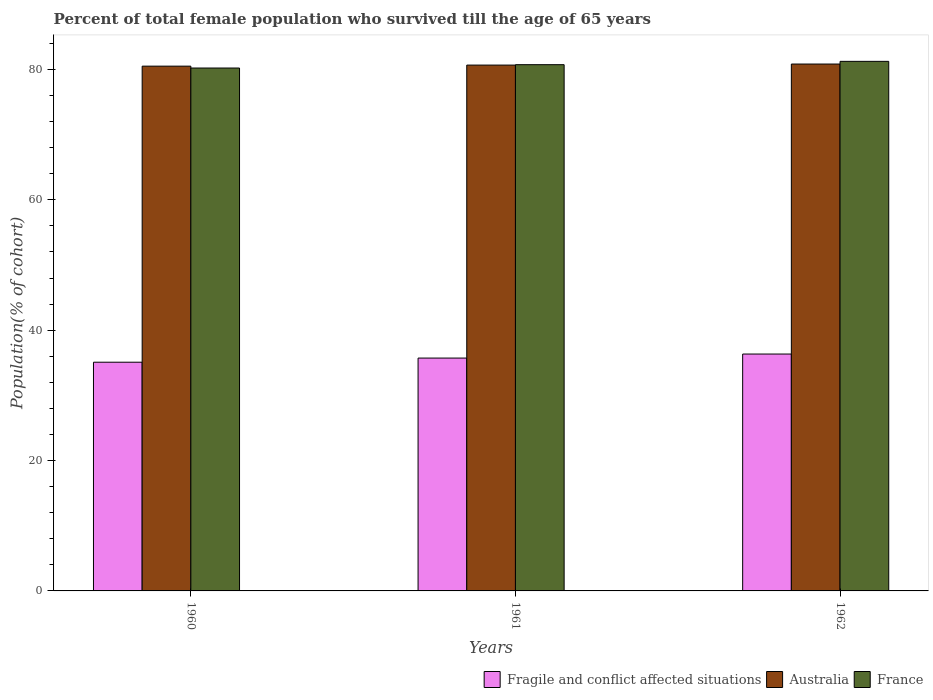How many different coloured bars are there?
Your answer should be compact. 3. How many groups of bars are there?
Offer a terse response. 3. What is the percentage of total female population who survived till the age of 65 years in France in 1960?
Your answer should be very brief. 80.21. Across all years, what is the maximum percentage of total female population who survived till the age of 65 years in Australia?
Keep it short and to the point. 80.82. Across all years, what is the minimum percentage of total female population who survived till the age of 65 years in France?
Ensure brevity in your answer.  80.21. In which year was the percentage of total female population who survived till the age of 65 years in France maximum?
Keep it short and to the point. 1962. In which year was the percentage of total female population who survived till the age of 65 years in Australia minimum?
Your response must be concise. 1960. What is the total percentage of total female population who survived till the age of 65 years in Fragile and conflict affected situations in the graph?
Make the answer very short. 107.14. What is the difference between the percentage of total female population who survived till the age of 65 years in Australia in 1961 and that in 1962?
Make the answer very short. -0.16. What is the difference between the percentage of total female population who survived till the age of 65 years in Fragile and conflict affected situations in 1962 and the percentage of total female population who survived till the age of 65 years in Australia in 1961?
Make the answer very short. -44.32. What is the average percentage of total female population who survived till the age of 65 years in Australia per year?
Your answer should be very brief. 80.66. In the year 1961, what is the difference between the percentage of total female population who survived till the age of 65 years in Australia and percentage of total female population who survived till the age of 65 years in France?
Make the answer very short. -0.06. In how many years, is the percentage of total female population who survived till the age of 65 years in France greater than 60 %?
Provide a succinct answer. 3. What is the ratio of the percentage of total female population who survived till the age of 65 years in Australia in 1961 to that in 1962?
Your answer should be compact. 1. What is the difference between the highest and the second highest percentage of total female population who survived till the age of 65 years in Australia?
Provide a succinct answer. 0.16. What is the difference between the highest and the lowest percentage of total female population who survived till the age of 65 years in France?
Provide a short and direct response. 1.02. In how many years, is the percentage of total female population who survived till the age of 65 years in Fragile and conflict affected situations greater than the average percentage of total female population who survived till the age of 65 years in Fragile and conflict affected situations taken over all years?
Your answer should be very brief. 2. What does the 3rd bar from the right in 1962 represents?
Make the answer very short. Fragile and conflict affected situations. How many bars are there?
Offer a very short reply. 9. Are all the bars in the graph horizontal?
Offer a very short reply. No. How many years are there in the graph?
Keep it short and to the point. 3. What is the difference between two consecutive major ticks on the Y-axis?
Your response must be concise. 20. Are the values on the major ticks of Y-axis written in scientific E-notation?
Ensure brevity in your answer.  No. What is the title of the graph?
Keep it short and to the point. Percent of total female population who survived till the age of 65 years. Does "Bulgaria" appear as one of the legend labels in the graph?
Offer a very short reply. No. What is the label or title of the Y-axis?
Keep it short and to the point. Population(% of cohort). What is the Population(% of cohort) of Fragile and conflict affected situations in 1960?
Give a very brief answer. 35.08. What is the Population(% of cohort) of Australia in 1960?
Provide a succinct answer. 80.5. What is the Population(% of cohort) of France in 1960?
Offer a very short reply. 80.21. What is the Population(% of cohort) in Fragile and conflict affected situations in 1961?
Your answer should be compact. 35.72. What is the Population(% of cohort) in Australia in 1961?
Make the answer very short. 80.66. What is the Population(% of cohort) of France in 1961?
Offer a terse response. 80.72. What is the Population(% of cohort) of Fragile and conflict affected situations in 1962?
Offer a very short reply. 36.34. What is the Population(% of cohort) of Australia in 1962?
Provide a succinct answer. 80.82. What is the Population(% of cohort) in France in 1962?
Offer a terse response. 81.23. Across all years, what is the maximum Population(% of cohort) in Fragile and conflict affected situations?
Your answer should be very brief. 36.34. Across all years, what is the maximum Population(% of cohort) of Australia?
Provide a short and direct response. 80.82. Across all years, what is the maximum Population(% of cohort) of France?
Your answer should be very brief. 81.23. Across all years, what is the minimum Population(% of cohort) of Fragile and conflict affected situations?
Provide a succinct answer. 35.08. Across all years, what is the minimum Population(% of cohort) in Australia?
Your answer should be compact. 80.5. Across all years, what is the minimum Population(% of cohort) in France?
Make the answer very short. 80.21. What is the total Population(% of cohort) of Fragile and conflict affected situations in the graph?
Offer a terse response. 107.14. What is the total Population(% of cohort) in Australia in the graph?
Provide a succinct answer. 241.98. What is the total Population(% of cohort) of France in the graph?
Your response must be concise. 242.17. What is the difference between the Population(% of cohort) in Fragile and conflict affected situations in 1960 and that in 1961?
Give a very brief answer. -0.63. What is the difference between the Population(% of cohort) in Australia in 1960 and that in 1961?
Keep it short and to the point. -0.16. What is the difference between the Population(% of cohort) in France in 1960 and that in 1961?
Offer a very short reply. -0.51. What is the difference between the Population(% of cohort) in Fragile and conflict affected situations in 1960 and that in 1962?
Provide a short and direct response. -1.25. What is the difference between the Population(% of cohort) of Australia in 1960 and that in 1962?
Provide a short and direct response. -0.32. What is the difference between the Population(% of cohort) of France in 1960 and that in 1962?
Keep it short and to the point. -1.02. What is the difference between the Population(% of cohort) in Fragile and conflict affected situations in 1961 and that in 1962?
Make the answer very short. -0.62. What is the difference between the Population(% of cohort) in Australia in 1961 and that in 1962?
Your response must be concise. -0.16. What is the difference between the Population(% of cohort) of France in 1961 and that in 1962?
Provide a succinct answer. -0.51. What is the difference between the Population(% of cohort) in Fragile and conflict affected situations in 1960 and the Population(% of cohort) in Australia in 1961?
Make the answer very short. -45.58. What is the difference between the Population(% of cohort) of Fragile and conflict affected situations in 1960 and the Population(% of cohort) of France in 1961?
Ensure brevity in your answer.  -45.64. What is the difference between the Population(% of cohort) in Australia in 1960 and the Population(% of cohort) in France in 1961?
Provide a short and direct response. -0.22. What is the difference between the Population(% of cohort) in Fragile and conflict affected situations in 1960 and the Population(% of cohort) in Australia in 1962?
Ensure brevity in your answer.  -45.74. What is the difference between the Population(% of cohort) of Fragile and conflict affected situations in 1960 and the Population(% of cohort) of France in 1962?
Offer a terse response. -46.15. What is the difference between the Population(% of cohort) of Australia in 1960 and the Population(% of cohort) of France in 1962?
Provide a succinct answer. -0.74. What is the difference between the Population(% of cohort) of Fragile and conflict affected situations in 1961 and the Population(% of cohort) of Australia in 1962?
Provide a short and direct response. -45.1. What is the difference between the Population(% of cohort) in Fragile and conflict affected situations in 1961 and the Population(% of cohort) in France in 1962?
Make the answer very short. -45.52. What is the difference between the Population(% of cohort) in Australia in 1961 and the Population(% of cohort) in France in 1962?
Make the answer very short. -0.57. What is the average Population(% of cohort) in Fragile and conflict affected situations per year?
Give a very brief answer. 35.71. What is the average Population(% of cohort) in Australia per year?
Keep it short and to the point. 80.66. What is the average Population(% of cohort) in France per year?
Provide a short and direct response. 80.72. In the year 1960, what is the difference between the Population(% of cohort) in Fragile and conflict affected situations and Population(% of cohort) in Australia?
Give a very brief answer. -45.42. In the year 1960, what is the difference between the Population(% of cohort) in Fragile and conflict affected situations and Population(% of cohort) in France?
Provide a short and direct response. -45.13. In the year 1960, what is the difference between the Population(% of cohort) in Australia and Population(% of cohort) in France?
Give a very brief answer. 0.29. In the year 1961, what is the difference between the Population(% of cohort) of Fragile and conflict affected situations and Population(% of cohort) of Australia?
Offer a terse response. -44.94. In the year 1961, what is the difference between the Population(% of cohort) in Fragile and conflict affected situations and Population(% of cohort) in France?
Offer a terse response. -45.01. In the year 1961, what is the difference between the Population(% of cohort) of Australia and Population(% of cohort) of France?
Make the answer very short. -0.06. In the year 1962, what is the difference between the Population(% of cohort) of Fragile and conflict affected situations and Population(% of cohort) of Australia?
Your answer should be very brief. -44.49. In the year 1962, what is the difference between the Population(% of cohort) of Fragile and conflict affected situations and Population(% of cohort) of France?
Make the answer very short. -44.9. In the year 1962, what is the difference between the Population(% of cohort) in Australia and Population(% of cohort) in France?
Keep it short and to the point. -0.41. What is the ratio of the Population(% of cohort) of Fragile and conflict affected situations in 1960 to that in 1961?
Provide a succinct answer. 0.98. What is the ratio of the Population(% of cohort) in France in 1960 to that in 1961?
Provide a succinct answer. 0.99. What is the ratio of the Population(% of cohort) of Fragile and conflict affected situations in 1960 to that in 1962?
Provide a short and direct response. 0.97. What is the ratio of the Population(% of cohort) in France in 1960 to that in 1962?
Offer a very short reply. 0.99. What is the ratio of the Population(% of cohort) of Fragile and conflict affected situations in 1961 to that in 1962?
Your answer should be very brief. 0.98. What is the ratio of the Population(% of cohort) of France in 1961 to that in 1962?
Your response must be concise. 0.99. What is the difference between the highest and the second highest Population(% of cohort) in Fragile and conflict affected situations?
Give a very brief answer. 0.62. What is the difference between the highest and the second highest Population(% of cohort) of Australia?
Keep it short and to the point. 0.16. What is the difference between the highest and the second highest Population(% of cohort) in France?
Your answer should be very brief. 0.51. What is the difference between the highest and the lowest Population(% of cohort) in Fragile and conflict affected situations?
Give a very brief answer. 1.25. What is the difference between the highest and the lowest Population(% of cohort) of Australia?
Your answer should be very brief. 0.32. What is the difference between the highest and the lowest Population(% of cohort) in France?
Provide a short and direct response. 1.02. 